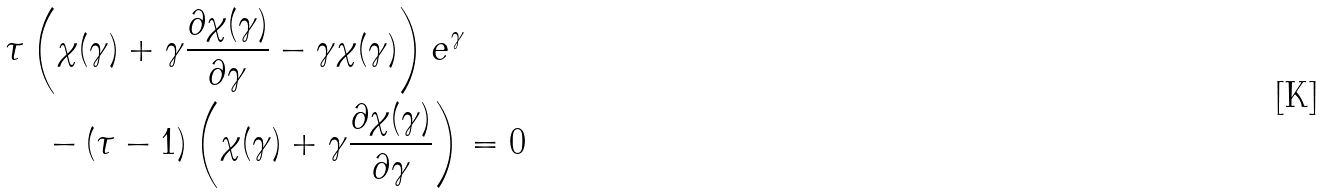<formula> <loc_0><loc_0><loc_500><loc_500>& \tau \left ( \chi ( \gamma ) + \gamma \frac { \partial \chi ( \gamma ) } { \partial \gamma } - \gamma \chi ( \gamma ) \right ) e ^ { \gamma } \\ & \quad - ( \tau - 1 ) \left ( \chi ( \gamma ) + \gamma \frac { \partial \chi ( \gamma ) } { \partial \gamma } \right ) = 0</formula> 